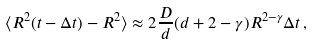Convert formula to latex. <formula><loc_0><loc_0><loc_500><loc_500>\langle R ^ { 2 } ( t - \Delta t ) - R ^ { 2 } \rangle \approx 2 \frac { D } { d } ( { d } + 2 - \gamma ) R ^ { 2 - \gamma } \Delta t \, ,</formula> 